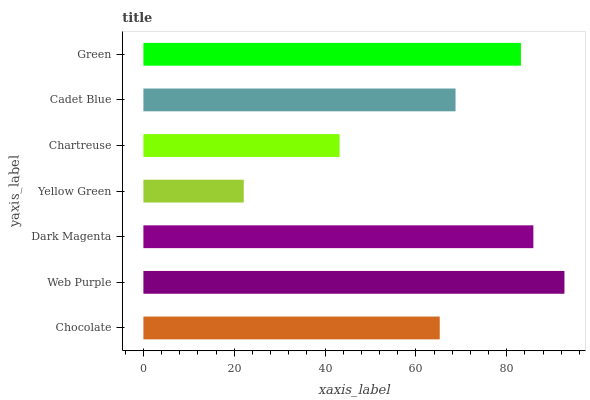Is Yellow Green the minimum?
Answer yes or no. Yes. Is Web Purple the maximum?
Answer yes or no. Yes. Is Dark Magenta the minimum?
Answer yes or no. No. Is Dark Magenta the maximum?
Answer yes or no. No. Is Web Purple greater than Dark Magenta?
Answer yes or no. Yes. Is Dark Magenta less than Web Purple?
Answer yes or no. Yes. Is Dark Magenta greater than Web Purple?
Answer yes or no. No. Is Web Purple less than Dark Magenta?
Answer yes or no. No. Is Cadet Blue the high median?
Answer yes or no. Yes. Is Cadet Blue the low median?
Answer yes or no. Yes. Is Chartreuse the high median?
Answer yes or no. No. Is Web Purple the low median?
Answer yes or no. No. 